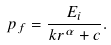Convert formula to latex. <formula><loc_0><loc_0><loc_500><loc_500>p _ { f } = \frac { E _ { i } } { k r ^ { \alpha } + c } .</formula> 